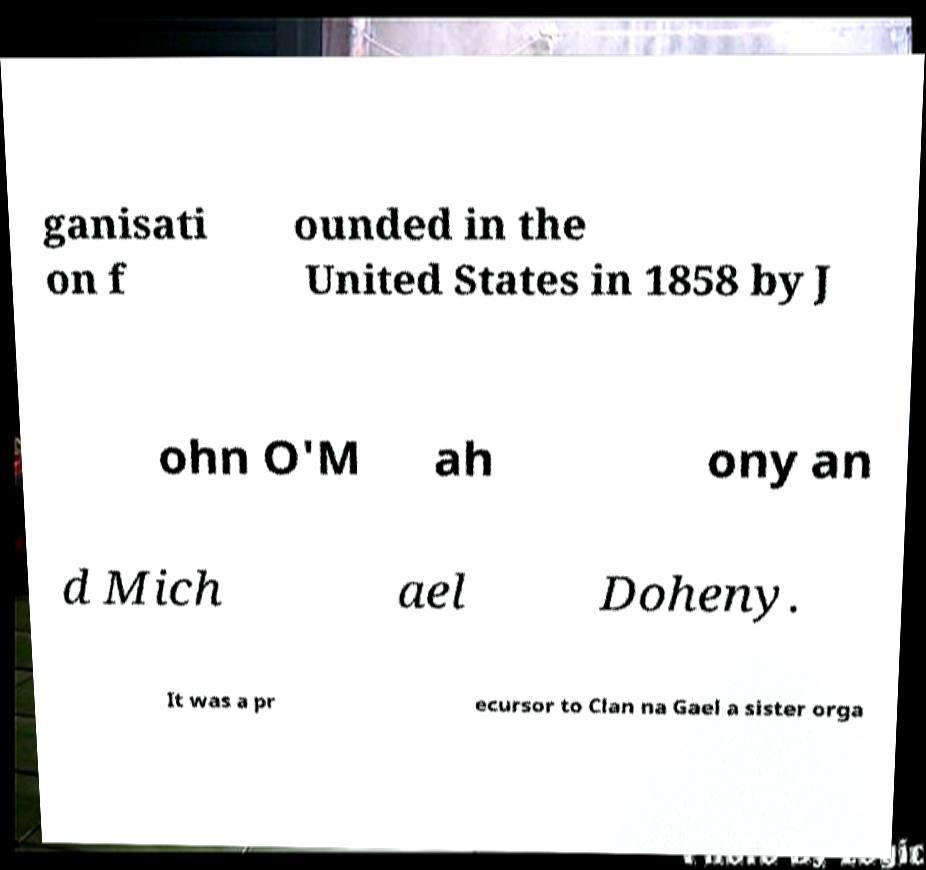There's text embedded in this image that I need extracted. Can you transcribe it verbatim? ganisati on f ounded in the United States in 1858 by J ohn O'M ah ony an d Mich ael Doheny. It was a pr ecursor to Clan na Gael a sister orga 